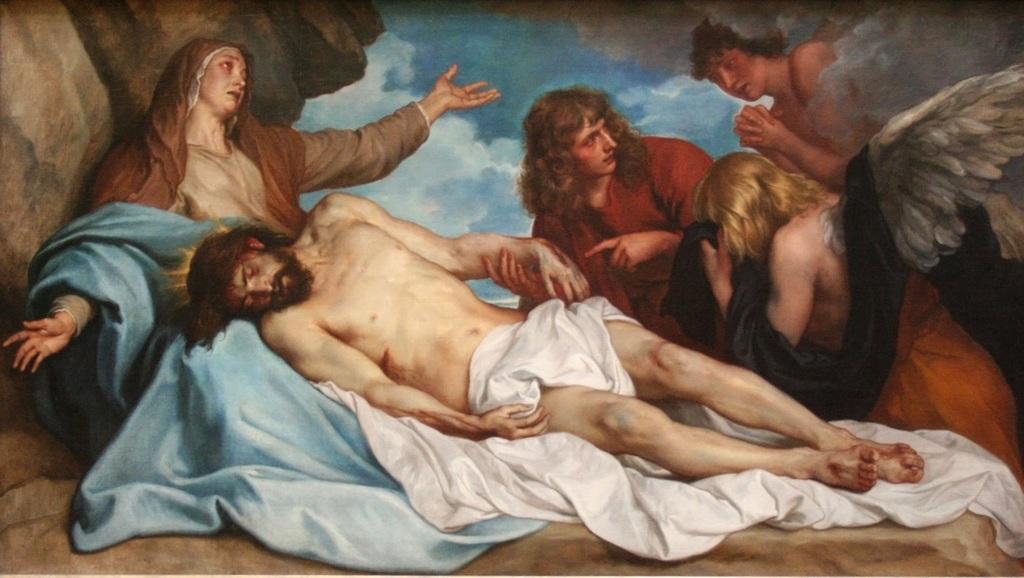How would you summarize this image in a sentence or two? In the image there is a painting of a man laying on a woman's lap with cloth around him and few people standing beside him and in the back there are clouds. 